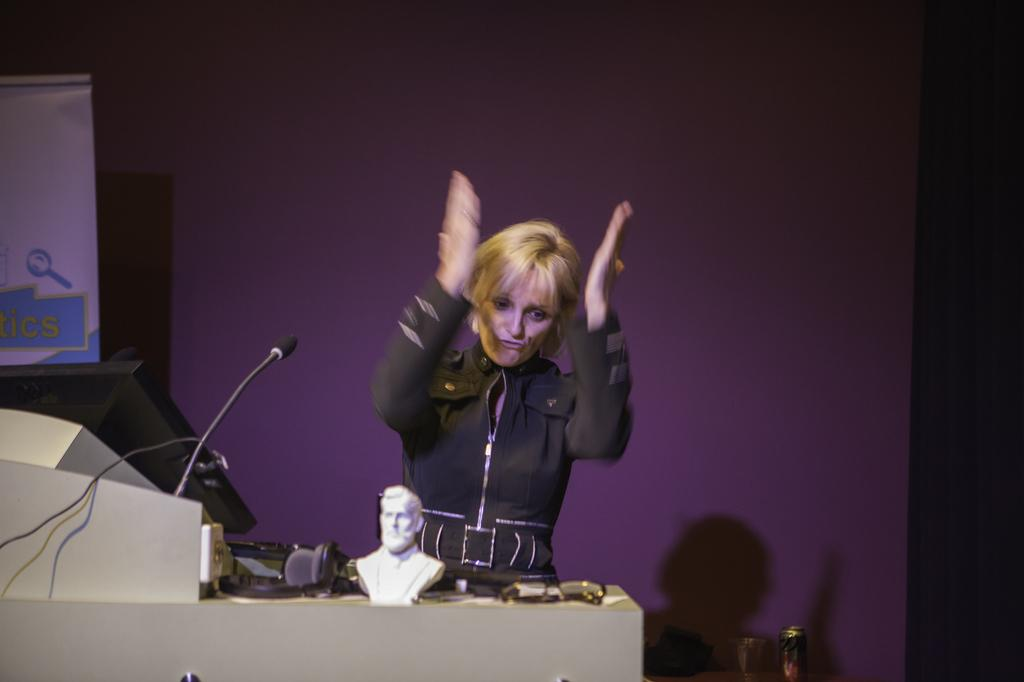What is the lady in the image doing? The lady is standing in the image. What is in front of the lady? There is a table in front of the lady. What can be found on the table? There are objects on the table, including a computer. What is on the wall behind the lady? There is a banner on the wall behind the lady. What type of tomatoes can be seen in the image? There are no tomatoes present in the image. What reason does the lady have for standing in the image? The image does not provide any information about the lady's reason for standing, so we cannot determine her motivation from the image alone. 